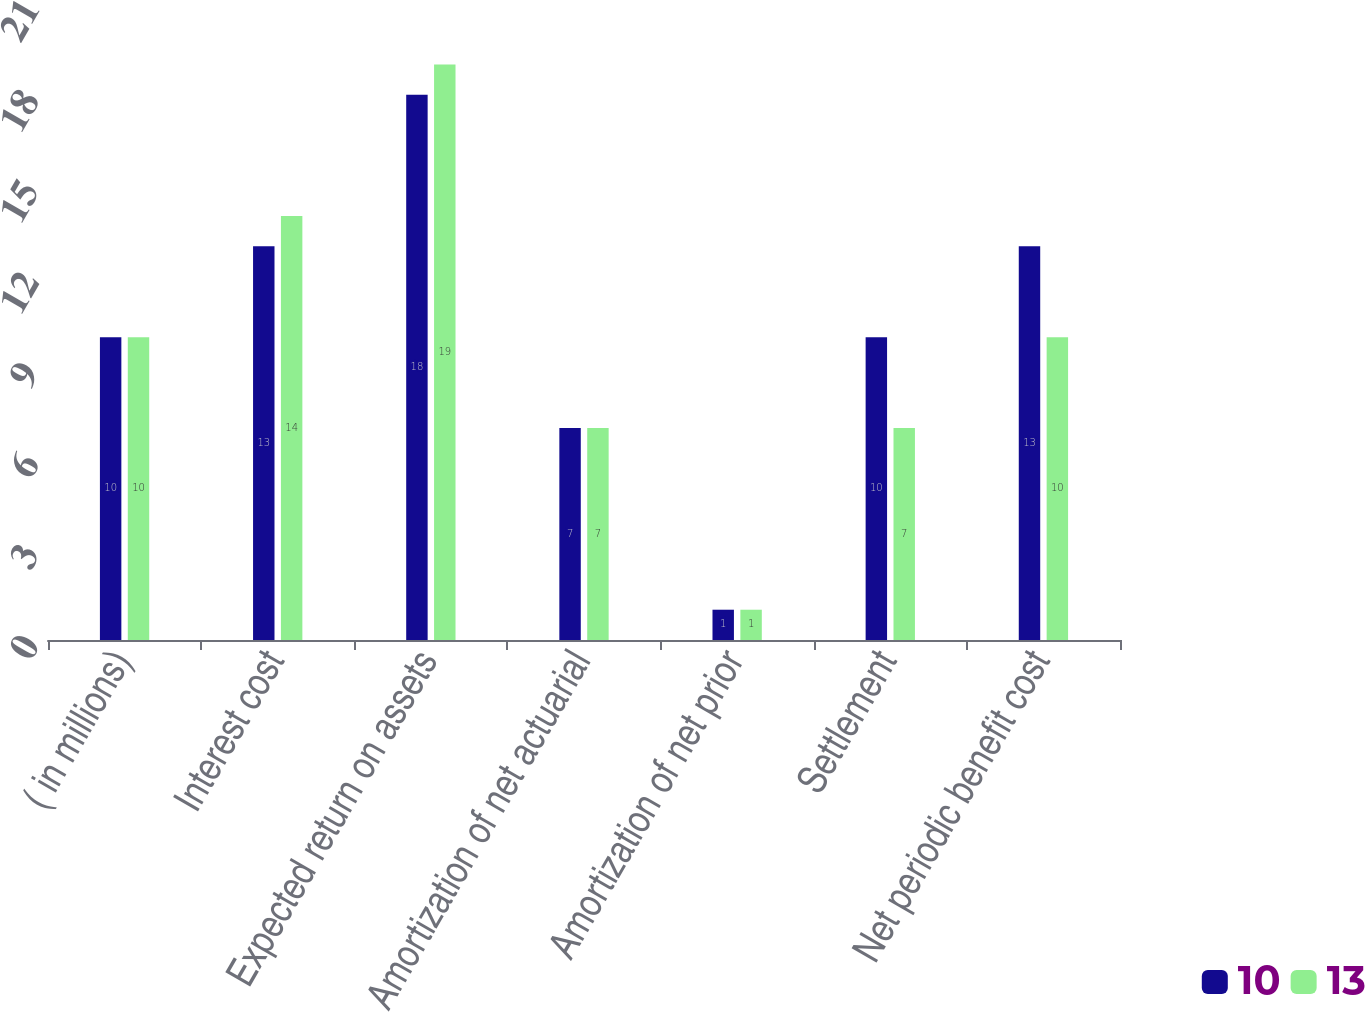<chart> <loc_0><loc_0><loc_500><loc_500><stacked_bar_chart><ecel><fcel>( in millions)<fcel>Interest cost<fcel>Expected return on assets<fcel>Amortization of net actuarial<fcel>Amortization of net prior<fcel>Settlement<fcel>Net periodic benefit cost<nl><fcel>10<fcel>10<fcel>13<fcel>18<fcel>7<fcel>1<fcel>10<fcel>13<nl><fcel>13<fcel>10<fcel>14<fcel>19<fcel>7<fcel>1<fcel>7<fcel>10<nl></chart> 